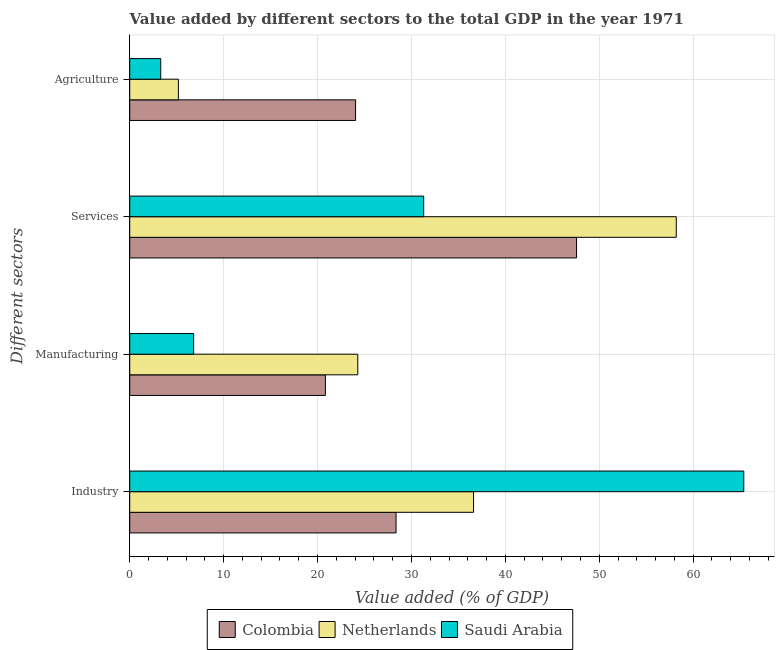How many different coloured bars are there?
Provide a succinct answer. 3. What is the label of the 2nd group of bars from the top?
Keep it short and to the point. Services. What is the value added by manufacturing sector in Netherlands?
Offer a terse response. 24.29. Across all countries, what is the maximum value added by manufacturing sector?
Offer a very short reply. 24.29. Across all countries, what is the minimum value added by manufacturing sector?
Your answer should be compact. 6.81. What is the total value added by services sector in the graph?
Provide a short and direct response. 137.09. What is the difference between the value added by industrial sector in Colombia and that in Saudi Arabia?
Offer a terse response. -37.03. What is the difference between the value added by manufacturing sector in Saudi Arabia and the value added by agricultural sector in Colombia?
Ensure brevity in your answer.  -17.25. What is the average value added by manufacturing sector per country?
Offer a terse response. 17.31. What is the difference between the value added by industrial sector and value added by agricultural sector in Saudi Arabia?
Your answer should be very brief. 62.09. What is the ratio of the value added by industrial sector in Netherlands to that in Colombia?
Ensure brevity in your answer.  1.29. Is the difference between the value added by services sector in Colombia and Netherlands greater than the difference between the value added by manufacturing sector in Colombia and Netherlands?
Provide a succinct answer. No. What is the difference between the highest and the second highest value added by services sector?
Your answer should be very brief. 10.62. What is the difference between the highest and the lowest value added by industrial sector?
Your answer should be very brief. 37.03. In how many countries, is the value added by manufacturing sector greater than the average value added by manufacturing sector taken over all countries?
Provide a succinct answer. 2. Is it the case that in every country, the sum of the value added by services sector and value added by industrial sector is greater than the sum of value added by manufacturing sector and value added by agricultural sector?
Your answer should be compact. Yes. What does the 2nd bar from the bottom in Services represents?
Your answer should be very brief. Netherlands. Are all the bars in the graph horizontal?
Your answer should be compact. Yes. Are the values on the major ticks of X-axis written in scientific E-notation?
Your response must be concise. No. Where does the legend appear in the graph?
Your answer should be very brief. Bottom center. How many legend labels are there?
Offer a very short reply. 3. What is the title of the graph?
Provide a short and direct response. Value added by different sectors to the total GDP in the year 1971. What is the label or title of the X-axis?
Your answer should be very brief. Value added (% of GDP). What is the label or title of the Y-axis?
Your answer should be very brief. Different sectors. What is the Value added (% of GDP) in Colombia in Industry?
Give a very brief answer. 28.36. What is the Value added (% of GDP) in Netherlands in Industry?
Your answer should be compact. 36.61. What is the Value added (% of GDP) in Saudi Arabia in Industry?
Your response must be concise. 65.39. What is the Value added (% of GDP) of Colombia in Manufacturing?
Your response must be concise. 20.84. What is the Value added (% of GDP) in Netherlands in Manufacturing?
Provide a short and direct response. 24.29. What is the Value added (% of GDP) of Saudi Arabia in Manufacturing?
Give a very brief answer. 6.81. What is the Value added (% of GDP) of Colombia in Services?
Your response must be concise. 47.58. What is the Value added (% of GDP) in Netherlands in Services?
Your answer should be compact. 58.2. What is the Value added (% of GDP) in Saudi Arabia in Services?
Provide a succinct answer. 31.31. What is the Value added (% of GDP) of Colombia in Agriculture?
Ensure brevity in your answer.  24.05. What is the Value added (% of GDP) in Netherlands in Agriculture?
Your answer should be very brief. 5.18. What is the Value added (% of GDP) in Saudi Arabia in Agriculture?
Give a very brief answer. 3.3. Across all Different sectors, what is the maximum Value added (% of GDP) of Colombia?
Keep it short and to the point. 47.58. Across all Different sectors, what is the maximum Value added (% of GDP) in Netherlands?
Make the answer very short. 58.2. Across all Different sectors, what is the maximum Value added (% of GDP) in Saudi Arabia?
Offer a very short reply. 65.39. Across all Different sectors, what is the minimum Value added (% of GDP) in Colombia?
Your answer should be very brief. 20.84. Across all Different sectors, what is the minimum Value added (% of GDP) in Netherlands?
Keep it short and to the point. 5.18. Across all Different sectors, what is the minimum Value added (% of GDP) of Saudi Arabia?
Your answer should be very brief. 3.3. What is the total Value added (% of GDP) in Colombia in the graph?
Keep it short and to the point. 120.84. What is the total Value added (% of GDP) of Netherlands in the graph?
Make the answer very short. 124.29. What is the total Value added (% of GDP) in Saudi Arabia in the graph?
Your answer should be very brief. 106.81. What is the difference between the Value added (% of GDP) of Colombia in Industry and that in Manufacturing?
Your answer should be very brief. 7.52. What is the difference between the Value added (% of GDP) of Netherlands in Industry and that in Manufacturing?
Your answer should be compact. 12.33. What is the difference between the Value added (% of GDP) of Saudi Arabia in Industry and that in Manufacturing?
Give a very brief answer. 58.59. What is the difference between the Value added (% of GDP) of Colombia in Industry and that in Services?
Provide a short and direct response. -19.22. What is the difference between the Value added (% of GDP) in Netherlands in Industry and that in Services?
Offer a terse response. -21.59. What is the difference between the Value added (% of GDP) in Saudi Arabia in Industry and that in Services?
Ensure brevity in your answer.  34.09. What is the difference between the Value added (% of GDP) in Colombia in Industry and that in Agriculture?
Ensure brevity in your answer.  4.31. What is the difference between the Value added (% of GDP) in Netherlands in Industry and that in Agriculture?
Your response must be concise. 31.43. What is the difference between the Value added (% of GDP) in Saudi Arabia in Industry and that in Agriculture?
Provide a short and direct response. 62.09. What is the difference between the Value added (% of GDP) in Colombia in Manufacturing and that in Services?
Offer a very short reply. -26.75. What is the difference between the Value added (% of GDP) of Netherlands in Manufacturing and that in Services?
Offer a very short reply. -33.92. What is the difference between the Value added (% of GDP) in Saudi Arabia in Manufacturing and that in Services?
Give a very brief answer. -24.5. What is the difference between the Value added (% of GDP) of Colombia in Manufacturing and that in Agriculture?
Give a very brief answer. -3.22. What is the difference between the Value added (% of GDP) in Netherlands in Manufacturing and that in Agriculture?
Your response must be concise. 19.1. What is the difference between the Value added (% of GDP) of Saudi Arabia in Manufacturing and that in Agriculture?
Your response must be concise. 3.51. What is the difference between the Value added (% of GDP) of Colombia in Services and that in Agriculture?
Give a very brief answer. 23.53. What is the difference between the Value added (% of GDP) of Netherlands in Services and that in Agriculture?
Your answer should be very brief. 53.02. What is the difference between the Value added (% of GDP) in Saudi Arabia in Services and that in Agriculture?
Offer a very short reply. 28.01. What is the difference between the Value added (% of GDP) in Colombia in Industry and the Value added (% of GDP) in Netherlands in Manufacturing?
Your response must be concise. 4.07. What is the difference between the Value added (% of GDP) in Colombia in Industry and the Value added (% of GDP) in Saudi Arabia in Manufacturing?
Give a very brief answer. 21.56. What is the difference between the Value added (% of GDP) in Netherlands in Industry and the Value added (% of GDP) in Saudi Arabia in Manufacturing?
Make the answer very short. 29.81. What is the difference between the Value added (% of GDP) of Colombia in Industry and the Value added (% of GDP) of Netherlands in Services?
Offer a very short reply. -29.84. What is the difference between the Value added (% of GDP) of Colombia in Industry and the Value added (% of GDP) of Saudi Arabia in Services?
Make the answer very short. -2.94. What is the difference between the Value added (% of GDP) in Netherlands in Industry and the Value added (% of GDP) in Saudi Arabia in Services?
Give a very brief answer. 5.31. What is the difference between the Value added (% of GDP) in Colombia in Industry and the Value added (% of GDP) in Netherlands in Agriculture?
Offer a very short reply. 23.18. What is the difference between the Value added (% of GDP) of Colombia in Industry and the Value added (% of GDP) of Saudi Arabia in Agriculture?
Your answer should be very brief. 25.06. What is the difference between the Value added (% of GDP) in Netherlands in Industry and the Value added (% of GDP) in Saudi Arabia in Agriculture?
Offer a terse response. 33.31. What is the difference between the Value added (% of GDP) of Colombia in Manufacturing and the Value added (% of GDP) of Netherlands in Services?
Make the answer very short. -37.36. What is the difference between the Value added (% of GDP) in Colombia in Manufacturing and the Value added (% of GDP) in Saudi Arabia in Services?
Keep it short and to the point. -10.47. What is the difference between the Value added (% of GDP) in Netherlands in Manufacturing and the Value added (% of GDP) in Saudi Arabia in Services?
Offer a terse response. -7.02. What is the difference between the Value added (% of GDP) in Colombia in Manufacturing and the Value added (% of GDP) in Netherlands in Agriculture?
Provide a succinct answer. 15.66. What is the difference between the Value added (% of GDP) of Colombia in Manufacturing and the Value added (% of GDP) of Saudi Arabia in Agriculture?
Your response must be concise. 17.54. What is the difference between the Value added (% of GDP) in Netherlands in Manufacturing and the Value added (% of GDP) in Saudi Arabia in Agriculture?
Keep it short and to the point. 20.99. What is the difference between the Value added (% of GDP) in Colombia in Services and the Value added (% of GDP) in Netherlands in Agriculture?
Provide a short and direct response. 42.4. What is the difference between the Value added (% of GDP) in Colombia in Services and the Value added (% of GDP) in Saudi Arabia in Agriculture?
Offer a very short reply. 44.28. What is the difference between the Value added (% of GDP) in Netherlands in Services and the Value added (% of GDP) in Saudi Arabia in Agriculture?
Your response must be concise. 54.9. What is the average Value added (% of GDP) of Colombia per Different sectors?
Provide a short and direct response. 30.21. What is the average Value added (% of GDP) of Netherlands per Different sectors?
Give a very brief answer. 31.07. What is the average Value added (% of GDP) of Saudi Arabia per Different sectors?
Provide a succinct answer. 26.7. What is the difference between the Value added (% of GDP) in Colombia and Value added (% of GDP) in Netherlands in Industry?
Your answer should be very brief. -8.25. What is the difference between the Value added (% of GDP) in Colombia and Value added (% of GDP) in Saudi Arabia in Industry?
Your answer should be very brief. -37.03. What is the difference between the Value added (% of GDP) of Netherlands and Value added (% of GDP) of Saudi Arabia in Industry?
Give a very brief answer. -28.78. What is the difference between the Value added (% of GDP) in Colombia and Value added (% of GDP) in Netherlands in Manufacturing?
Make the answer very short. -3.45. What is the difference between the Value added (% of GDP) in Colombia and Value added (% of GDP) in Saudi Arabia in Manufacturing?
Offer a terse response. 14.03. What is the difference between the Value added (% of GDP) of Netherlands and Value added (% of GDP) of Saudi Arabia in Manufacturing?
Your answer should be compact. 17.48. What is the difference between the Value added (% of GDP) in Colombia and Value added (% of GDP) in Netherlands in Services?
Your answer should be very brief. -10.62. What is the difference between the Value added (% of GDP) in Colombia and Value added (% of GDP) in Saudi Arabia in Services?
Keep it short and to the point. 16.28. What is the difference between the Value added (% of GDP) in Netherlands and Value added (% of GDP) in Saudi Arabia in Services?
Offer a terse response. 26.9. What is the difference between the Value added (% of GDP) in Colombia and Value added (% of GDP) in Netherlands in Agriculture?
Your response must be concise. 18.87. What is the difference between the Value added (% of GDP) in Colombia and Value added (% of GDP) in Saudi Arabia in Agriculture?
Give a very brief answer. 20.75. What is the difference between the Value added (% of GDP) of Netherlands and Value added (% of GDP) of Saudi Arabia in Agriculture?
Your answer should be compact. 1.88. What is the ratio of the Value added (% of GDP) of Colombia in Industry to that in Manufacturing?
Give a very brief answer. 1.36. What is the ratio of the Value added (% of GDP) of Netherlands in Industry to that in Manufacturing?
Offer a very short reply. 1.51. What is the ratio of the Value added (% of GDP) in Saudi Arabia in Industry to that in Manufacturing?
Your answer should be very brief. 9.61. What is the ratio of the Value added (% of GDP) of Colombia in Industry to that in Services?
Make the answer very short. 0.6. What is the ratio of the Value added (% of GDP) in Netherlands in Industry to that in Services?
Provide a short and direct response. 0.63. What is the ratio of the Value added (% of GDP) in Saudi Arabia in Industry to that in Services?
Keep it short and to the point. 2.09. What is the ratio of the Value added (% of GDP) in Colombia in Industry to that in Agriculture?
Keep it short and to the point. 1.18. What is the ratio of the Value added (% of GDP) in Netherlands in Industry to that in Agriculture?
Your answer should be compact. 7.06. What is the ratio of the Value added (% of GDP) in Saudi Arabia in Industry to that in Agriculture?
Provide a succinct answer. 19.81. What is the ratio of the Value added (% of GDP) in Colombia in Manufacturing to that in Services?
Keep it short and to the point. 0.44. What is the ratio of the Value added (% of GDP) of Netherlands in Manufacturing to that in Services?
Provide a succinct answer. 0.42. What is the ratio of the Value added (% of GDP) of Saudi Arabia in Manufacturing to that in Services?
Ensure brevity in your answer.  0.22. What is the ratio of the Value added (% of GDP) of Colombia in Manufacturing to that in Agriculture?
Make the answer very short. 0.87. What is the ratio of the Value added (% of GDP) in Netherlands in Manufacturing to that in Agriculture?
Give a very brief answer. 4.69. What is the ratio of the Value added (% of GDP) of Saudi Arabia in Manufacturing to that in Agriculture?
Your answer should be very brief. 2.06. What is the ratio of the Value added (% of GDP) in Colombia in Services to that in Agriculture?
Keep it short and to the point. 1.98. What is the ratio of the Value added (% of GDP) of Netherlands in Services to that in Agriculture?
Offer a very short reply. 11.23. What is the ratio of the Value added (% of GDP) in Saudi Arabia in Services to that in Agriculture?
Offer a terse response. 9.48. What is the difference between the highest and the second highest Value added (% of GDP) in Colombia?
Your answer should be compact. 19.22. What is the difference between the highest and the second highest Value added (% of GDP) in Netherlands?
Provide a succinct answer. 21.59. What is the difference between the highest and the second highest Value added (% of GDP) in Saudi Arabia?
Keep it short and to the point. 34.09. What is the difference between the highest and the lowest Value added (% of GDP) of Colombia?
Your response must be concise. 26.75. What is the difference between the highest and the lowest Value added (% of GDP) of Netherlands?
Offer a very short reply. 53.02. What is the difference between the highest and the lowest Value added (% of GDP) of Saudi Arabia?
Provide a succinct answer. 62.09. 